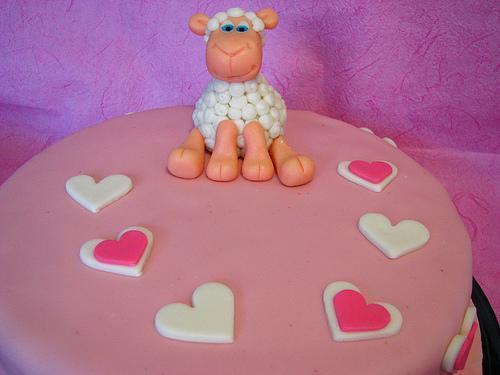Does the description: "The sheep is at the edge of the cake." accurately reflect the image?
Answer yes or no. Yes. 